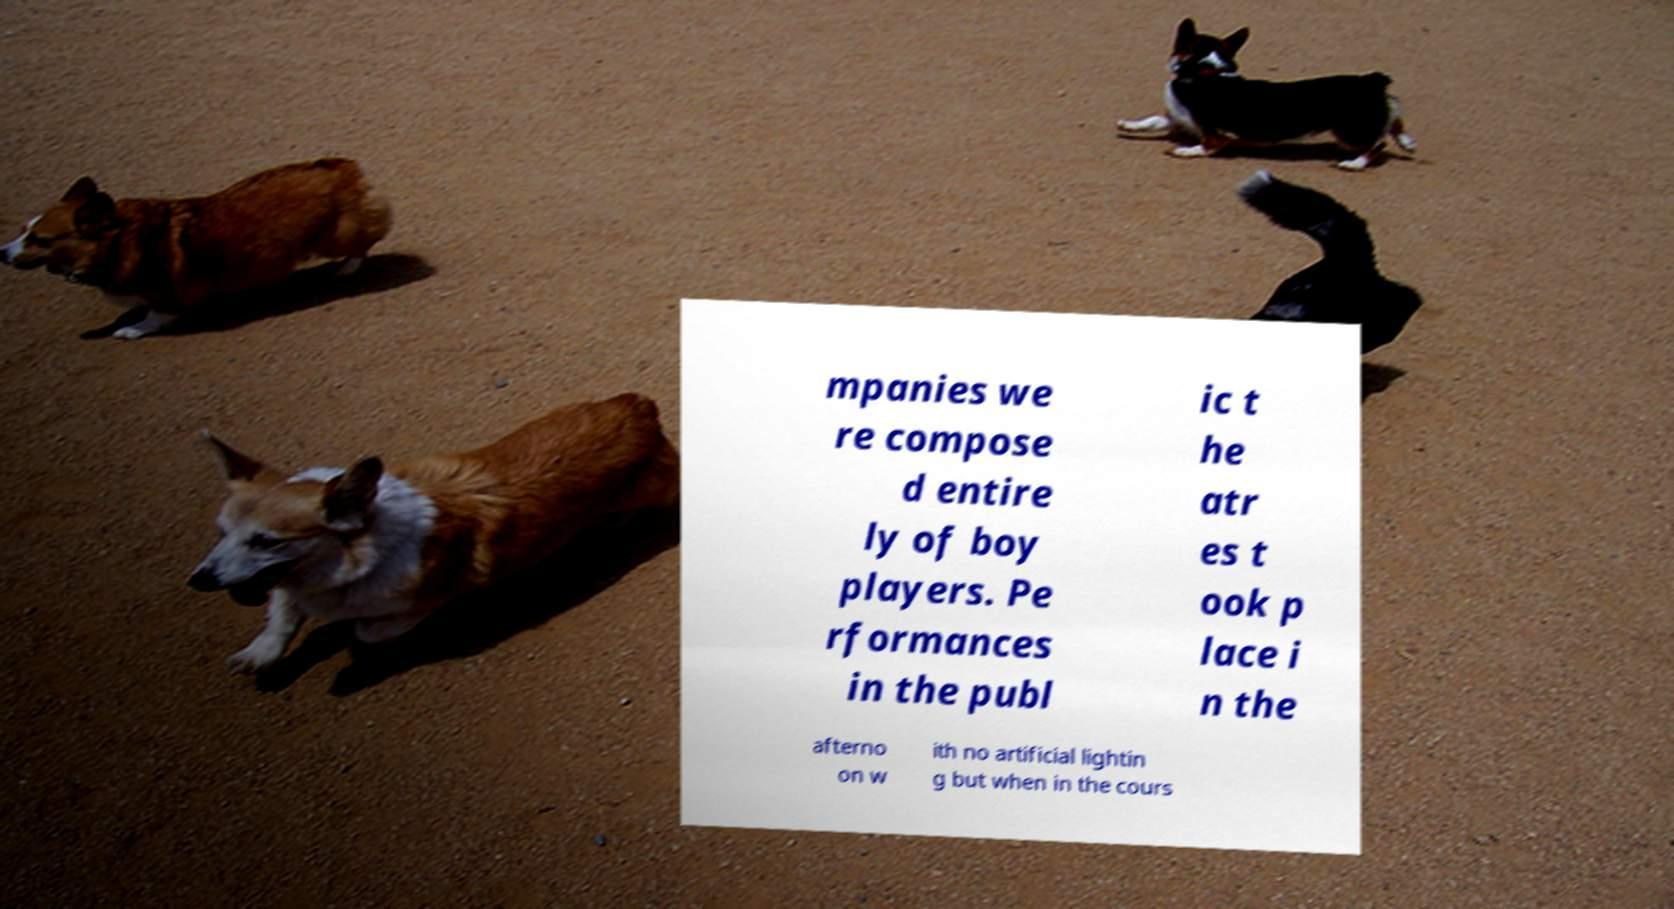Could you assist in decoding the text presented in this image and type it out clearly? mpanies we re compose d entire ly of boy players. Pe rformances in the publ ic t he atr es t ook p lace i n the afterno on w ith no artificial lightin g but when in the cours 